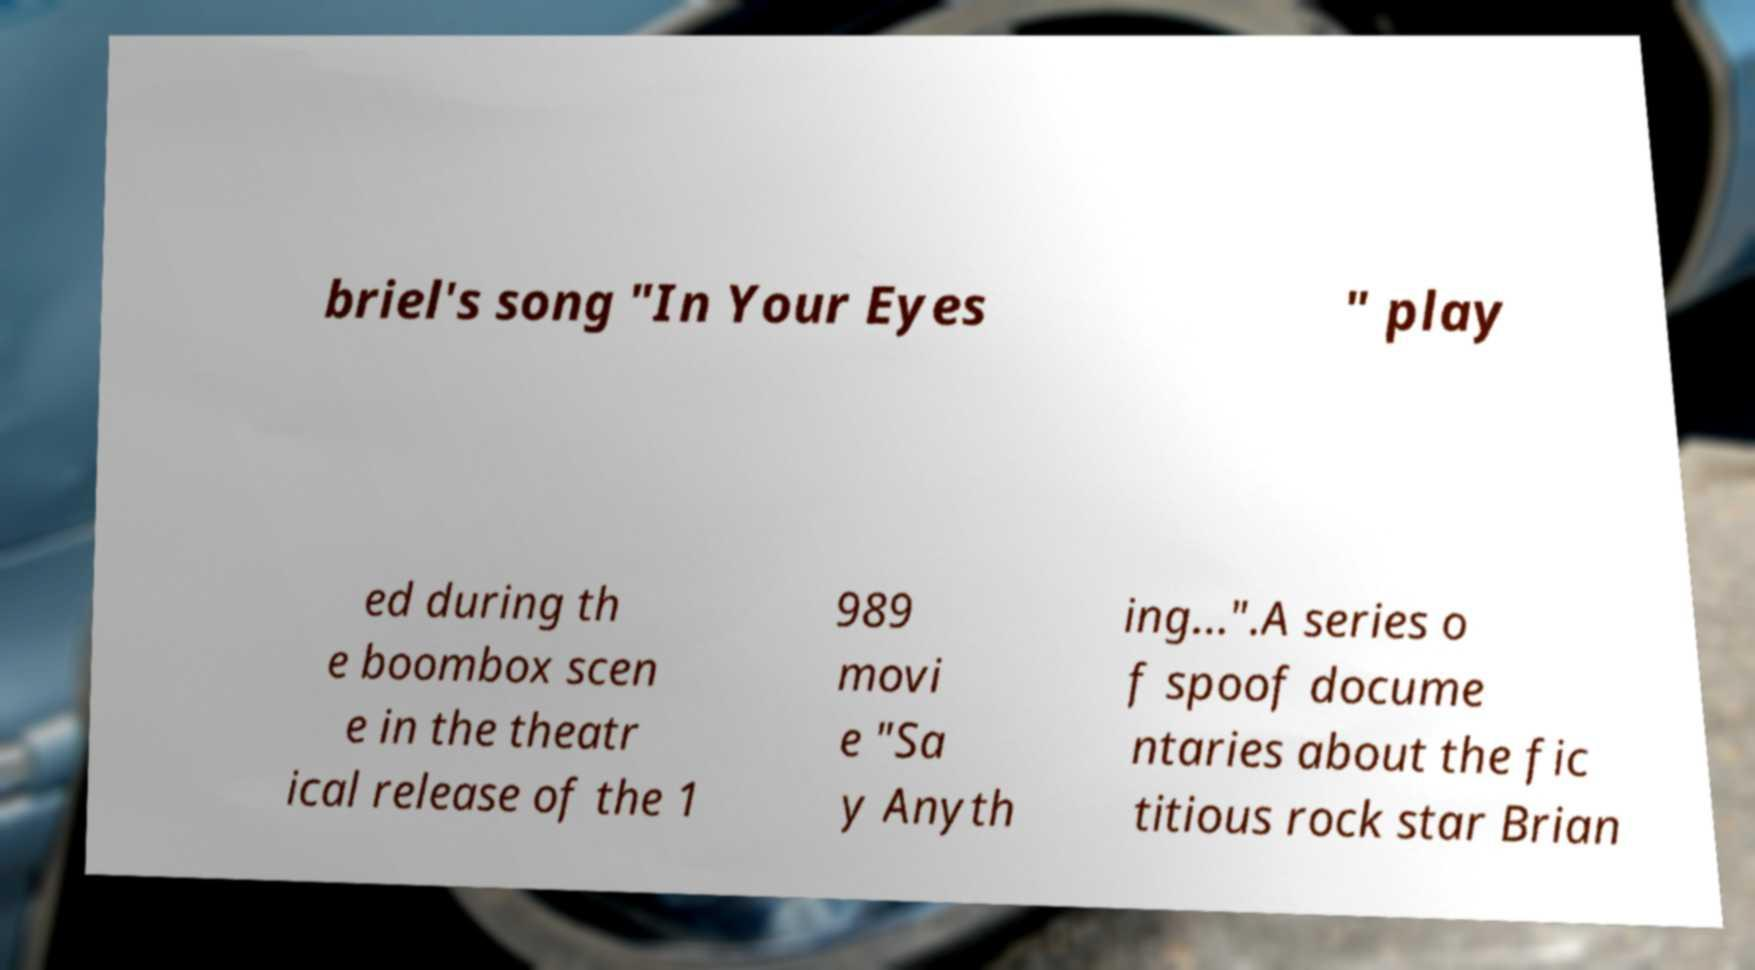Could you assist in decoding the text presented in this image and type it out clearly? briel's song "In Your Eyes " play ed during th e boombox scen e in the theatr ical release of the 1 989 movi e "Sa y Anyth ing...".A series o f spoof docume ntaries about the fic titious rock star Brian 